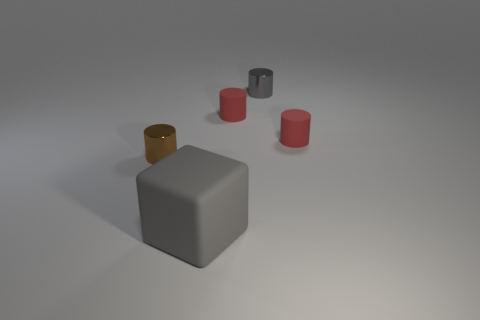How does the lighting affect the appearance of the objects? The soft, diffused light in the image highlights the textures of the objects, enhancing their contours and the visual impact of their surfaces. The glossy objects reflect light, which emphasizes their smoothness and adds depth, whereas the matte objects absorb light, which softens their appearance and highlights their shape. 